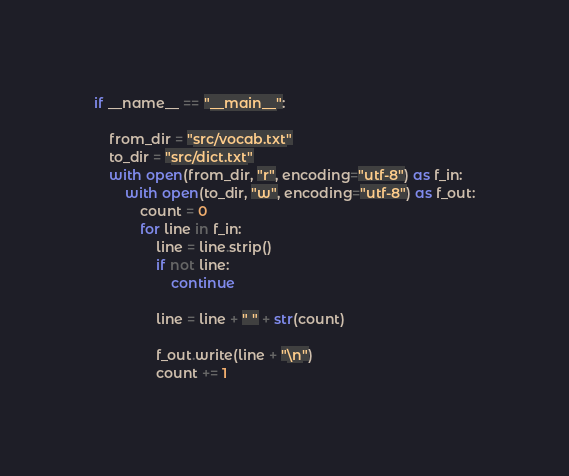<code> <loc_0><loc_0><loc_500><loc_500><_Python_>



if __name__ == "__main__":

    from_dir = "src/vocab.txt"
    to_dir = "src/dict.txt"
    with open(from_dir, "r", encoding="utf-8") as f_in:
        with open(to_dir, "w", encoding="utf-8") as f_out:
            count = 0
            for line in f_in:
                line = line.strip()
                if not line:
                    continue

                line = line + " " + str(count)

                f_out.write(line + "\n")
                count += 1

</code> 